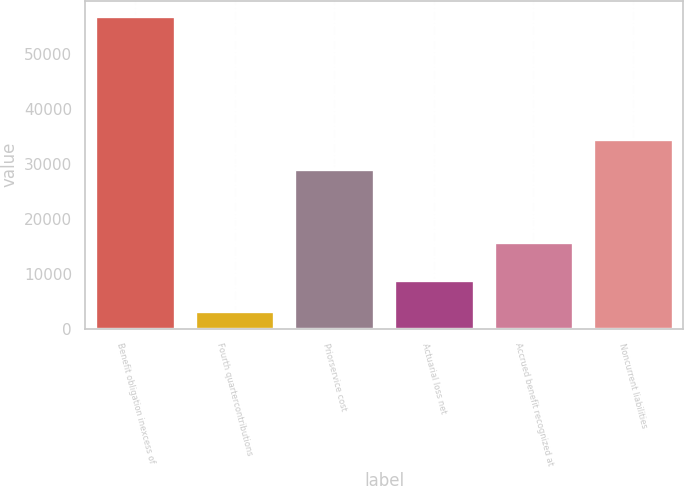Convert chart. <chart><loc_0><loc_0><loc_500><loc_500><bar_chart><fcel>Benefit obligation inexcess of<fcel>Fourth quartercontributions<fcel>Priorservice cost<fcel>Actuarial loss net<fcel>Accrued benefit recognized at<fcel>Noncurrent liabilities<nl><fcel>56891<fcel>3125<fcel>29089<fcel>8874<fcel>15803<fcel>34465.6<nl></chart> 